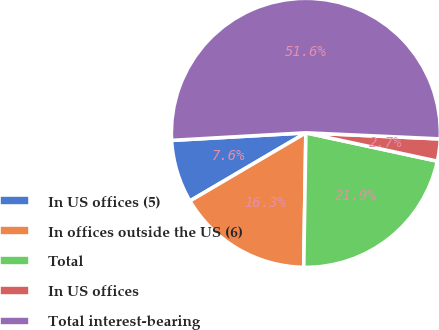Convert chart. <chart><loc_0><loc_0><loc_500><loc_500><pie_chart><fcel>In US offices (5)<fcel>In offices outside the US (6)<fcel>Total<fcel>In US offices<fcel>Total interest-bearing<nl><fcel>7.56%<fcel>16.29%<fcel>21.88%<fcel>2.66%<fcel>51.62%<nl></chart> 